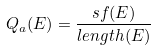<formula> <loc_0><loc_0><loc_500><loc_500>Q _ { a } ( E ) = \frac { s f ( E ) } { l e n g t h ( E ) }</formula> 